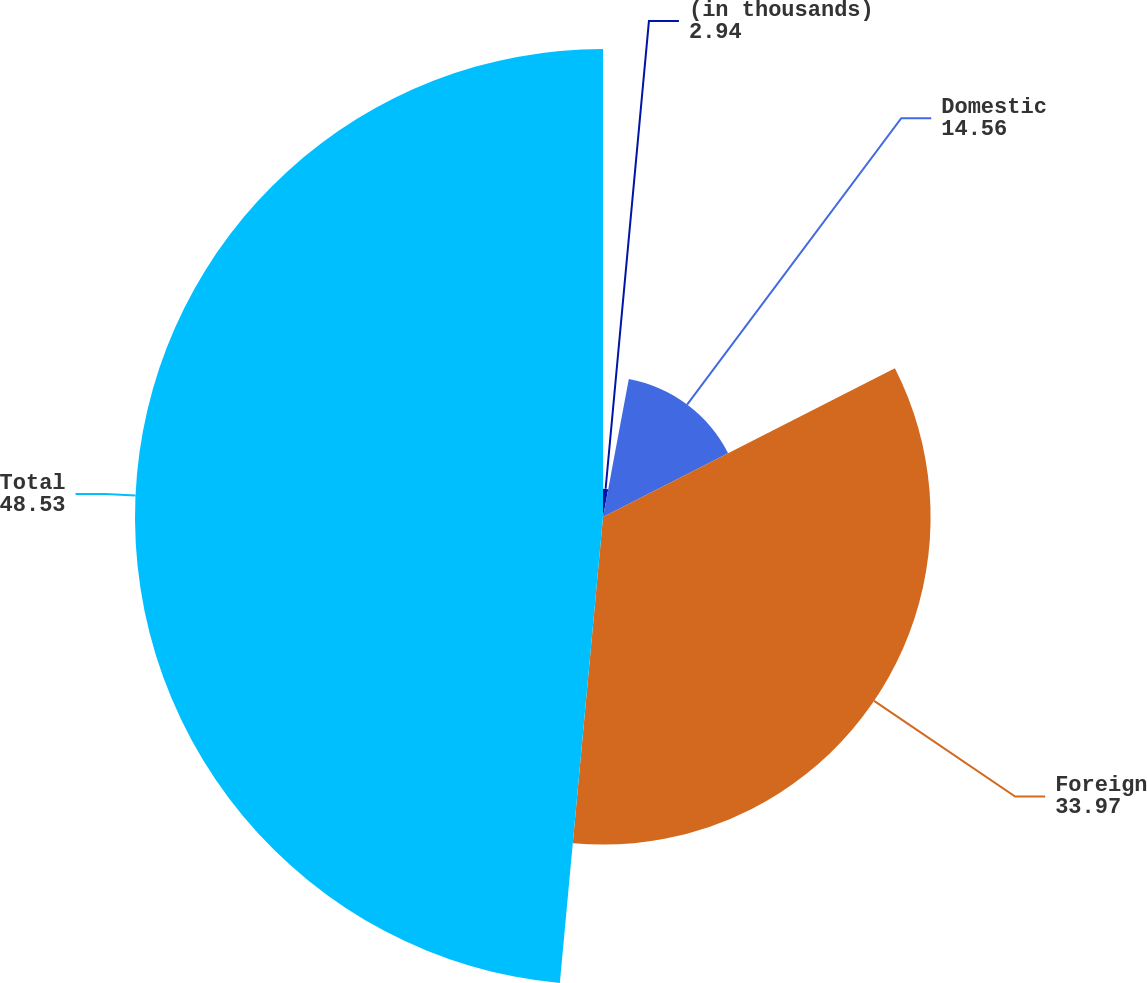<chart> <loc_0><loc_0><loc_500><loc_500><pie_chart><fcel>(in thousands)<fcel>Domestic<fcel>Foreign<fcel>Total<nl><fcel>2.94%<fcel>14.56%<fcel>33.97%<fcel>48.53%<nl></chart> 